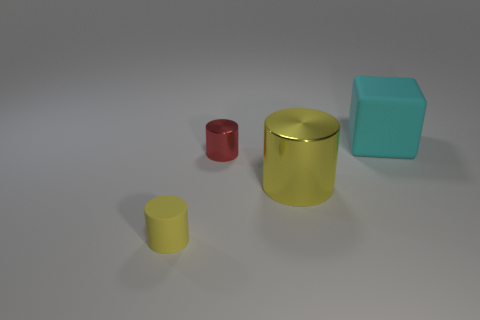The big rubber cube is what color? cyan 